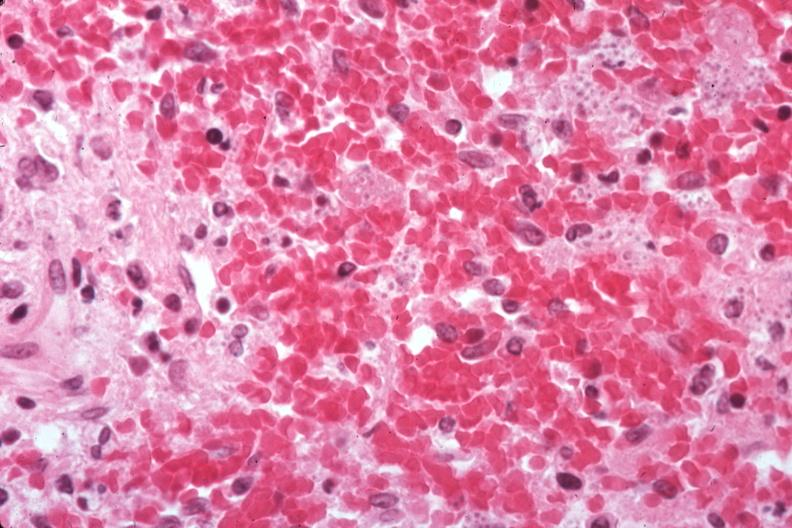what is present?
Answer the question using a single word or phrase. Hematologic 